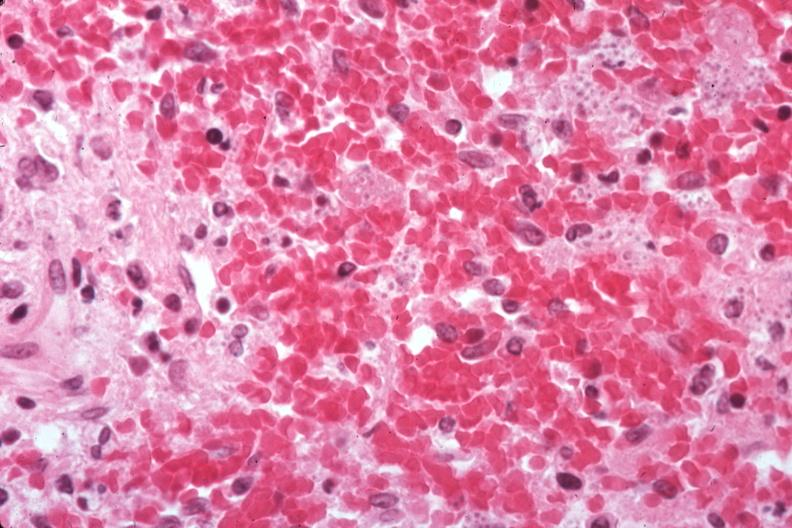what is present?
Answer the question using a single word or phrase. Hematologic 